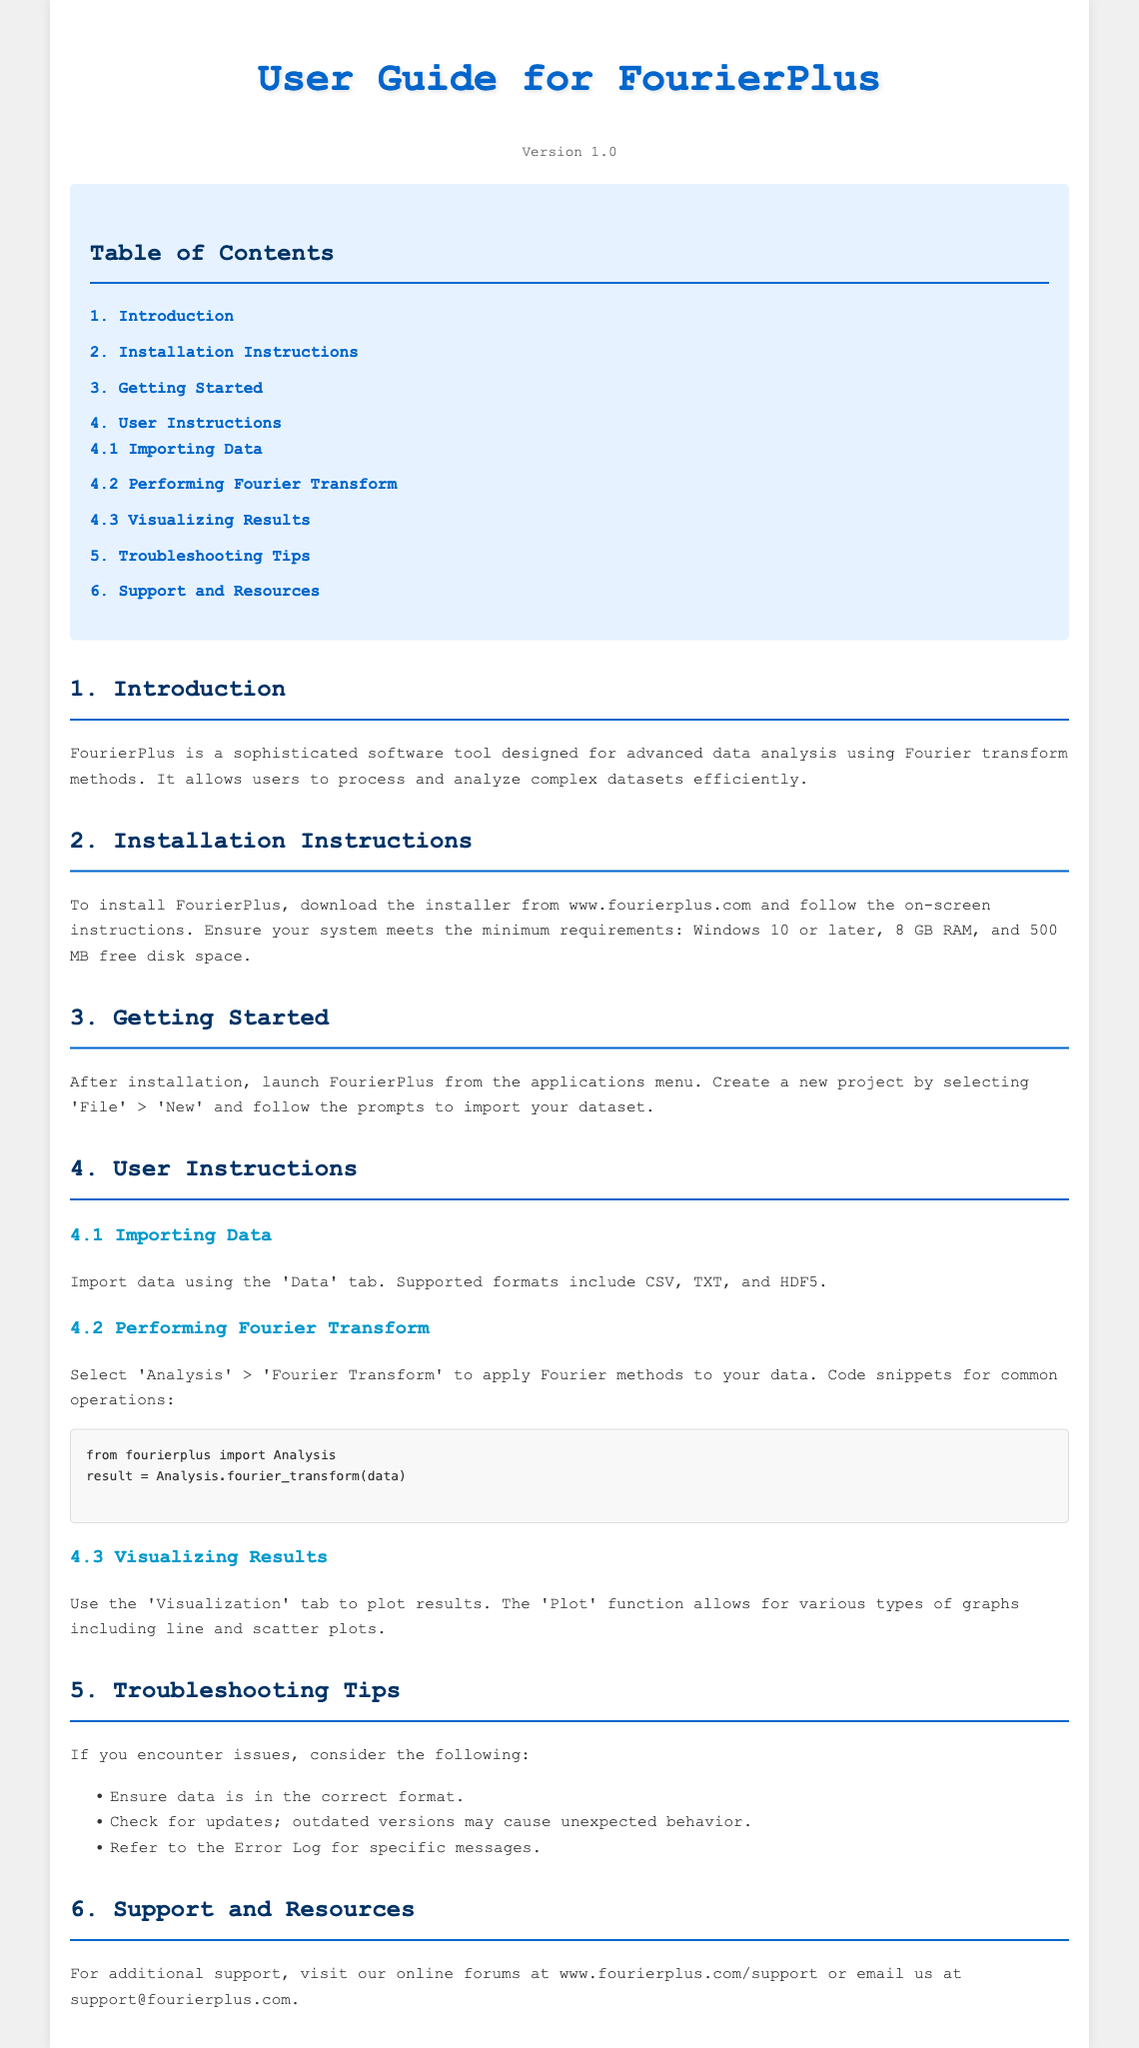What is the title of the software? The title of the software is found in the header of the document, which describes it as an advanced data analysis software using Fourier methods.
Answer: FourierPlus: Advanced Data Analysis Software What is the version number of FourierPlus? The version number can be found in the version section, noting the current release of the software.
Answer: Version 1.0 What is the minimum RAM requirement? The minimum RAM requirement is specified in the installation instructions, detailing system requirements for optimal performance.
Answer: 8 GB RAM Which file formats are supported for data importing? Supported formats are listed under the importing data section, specifying what users can import into the application for analysis.
Answer: CSV, TXT, HDF5 What menu option allows you to perform a Fourier Transform? The menu option for executing a Fourier transform is found in the user instructions, guiding users on where to go in the software.
Answer: Analysis > Fourier Transform What function is used for visualizing results? The specific function for visualizing results is mentioned in the user instructions under the visualization section of the document.
Answer: Plot What should you check if you encounter issues? The troubleshooting section lists several considerations to review if problems arise while using the software.
Answer: Data format, updates, Error Log Where can you find online support? The online support resources are provided in the last section of the document, indicating where users can go for help.
Answer: www.fourierplus.com/support 